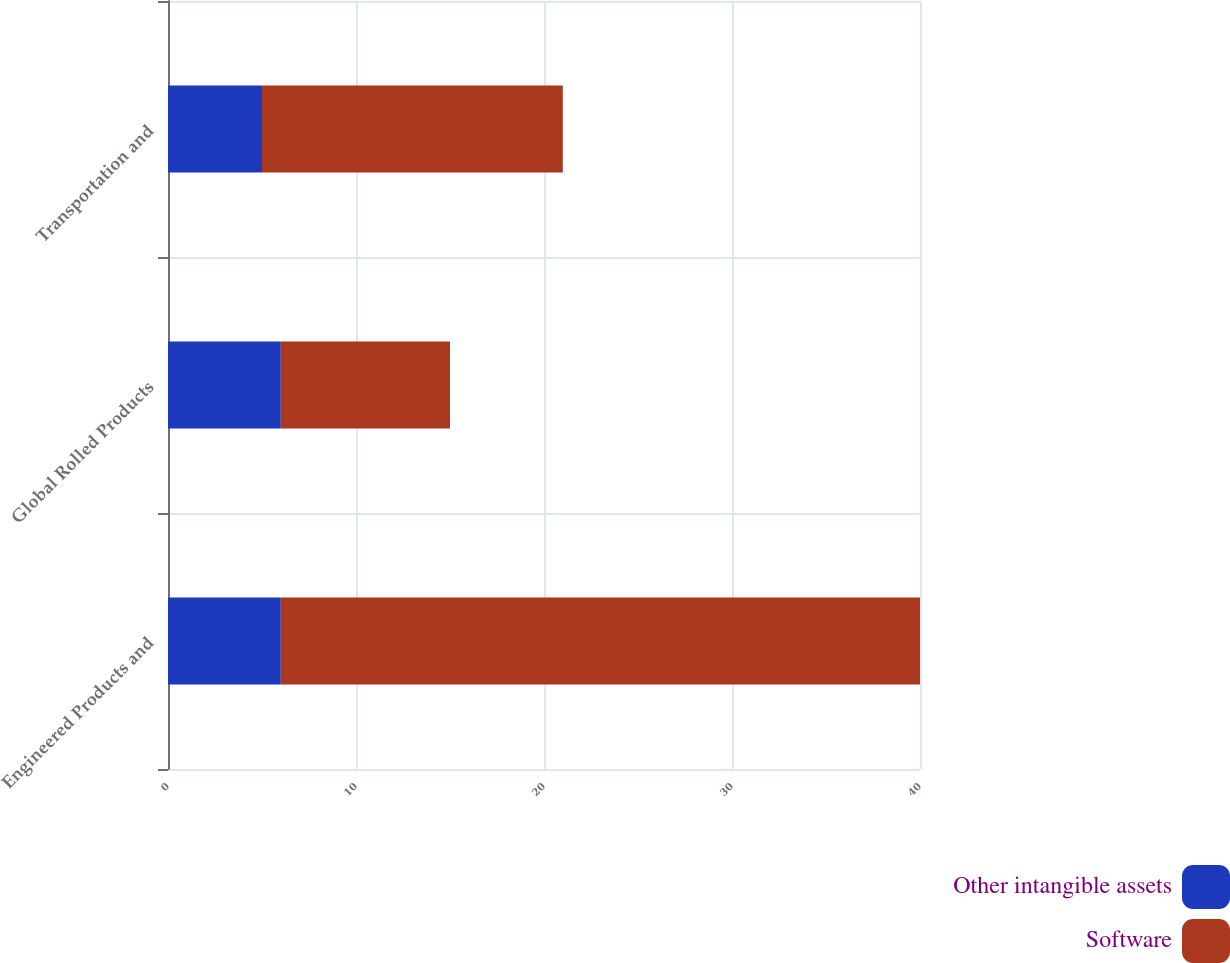Convert chart. <chart><loc_0><loc_0><loc_500><loc_500><stacked_bar_chart><ecel><fcel>Engineered Products and<fcel>Global Rolled Products<fcel>Transportation and<nl><fcel>Other intangible assets<fcel>6<fcel>6<fcel>5<nl><fcel>Software<fcel>34<fcel>9<fcel>16<nl></chart> 